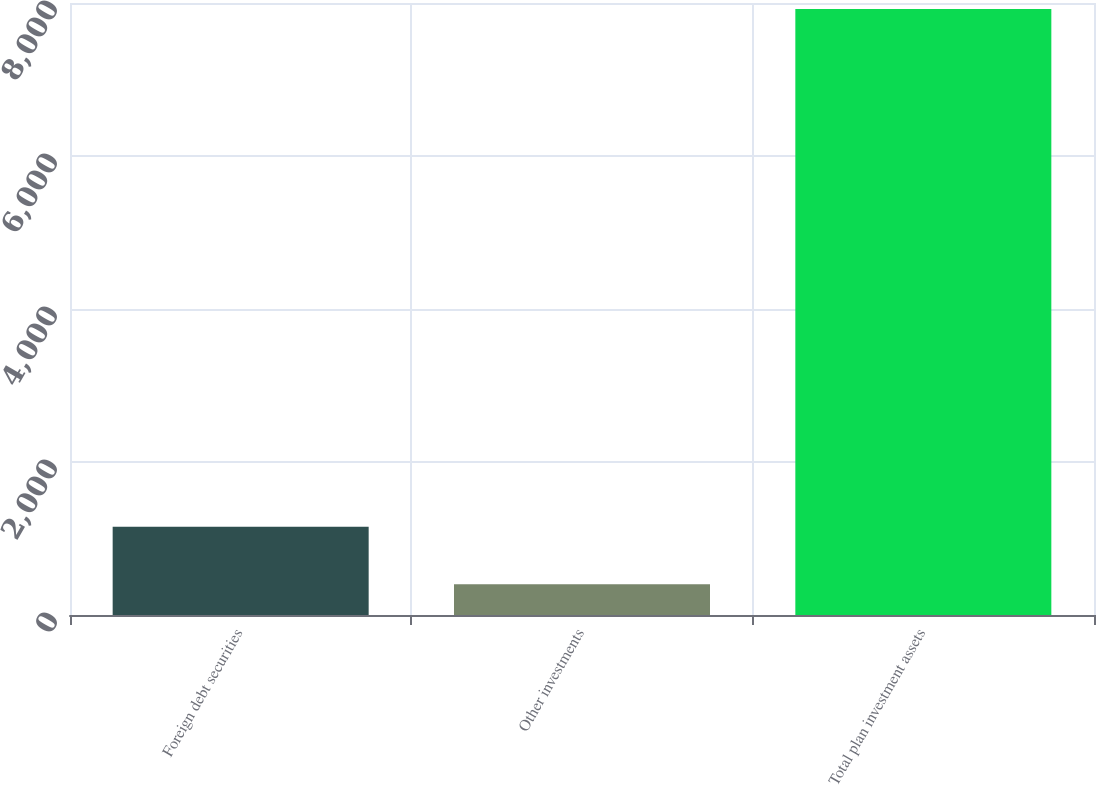Convert chart. <chart><loc_0><loc_0><loc_500><loc_500><bar_chart><fcel>Foreign debt securities<fcel>Other investments<fcel>Total plan investment assets<nl><fcel>1154.1<fcel>402<fcel>7923<nl></chart> 